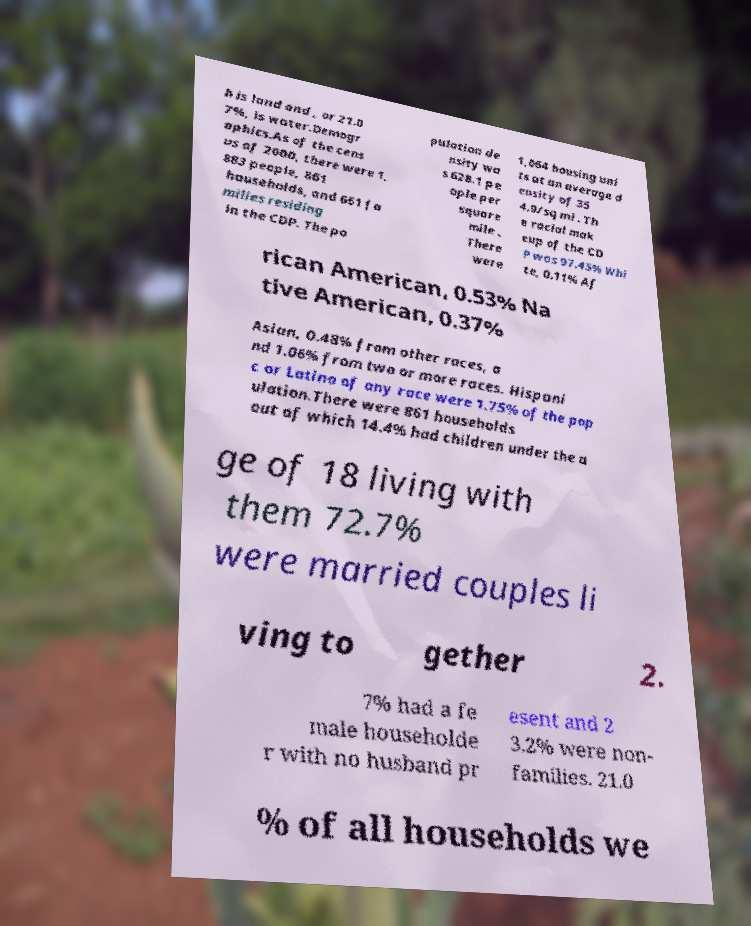Please identify and transcribe the text found in this image. h is land and , or 21.0 7%, is water.Demogr aphics.As of the cens us of 2000, there were 1, 883 people, 861 households, and 661 fa milies residing in the CDP. The po pulation de nsity wa s 628.1 pe ople per square mile . There were 1,064 housing uni ts at an average d ensity of 35 4.9/sq mi . Th e racial mak eup of the CD P was 97.45% Whi te, 0.11% Af rican American, 0.53% Na tive American, 0.37% Asian, 0.48% from other races, a nd 1.06% from two or more races. Hispani c or Latino of any race were 1.75% of the pop ulation.There were 861 households out of which 14.4% had children under the a ge of 18 living with them 72.7% were married couples li ving to gether 2. 7% had a fe male householde r with no husband pr esent and 2 3.2% were non- families. 21.0 % of all households we 